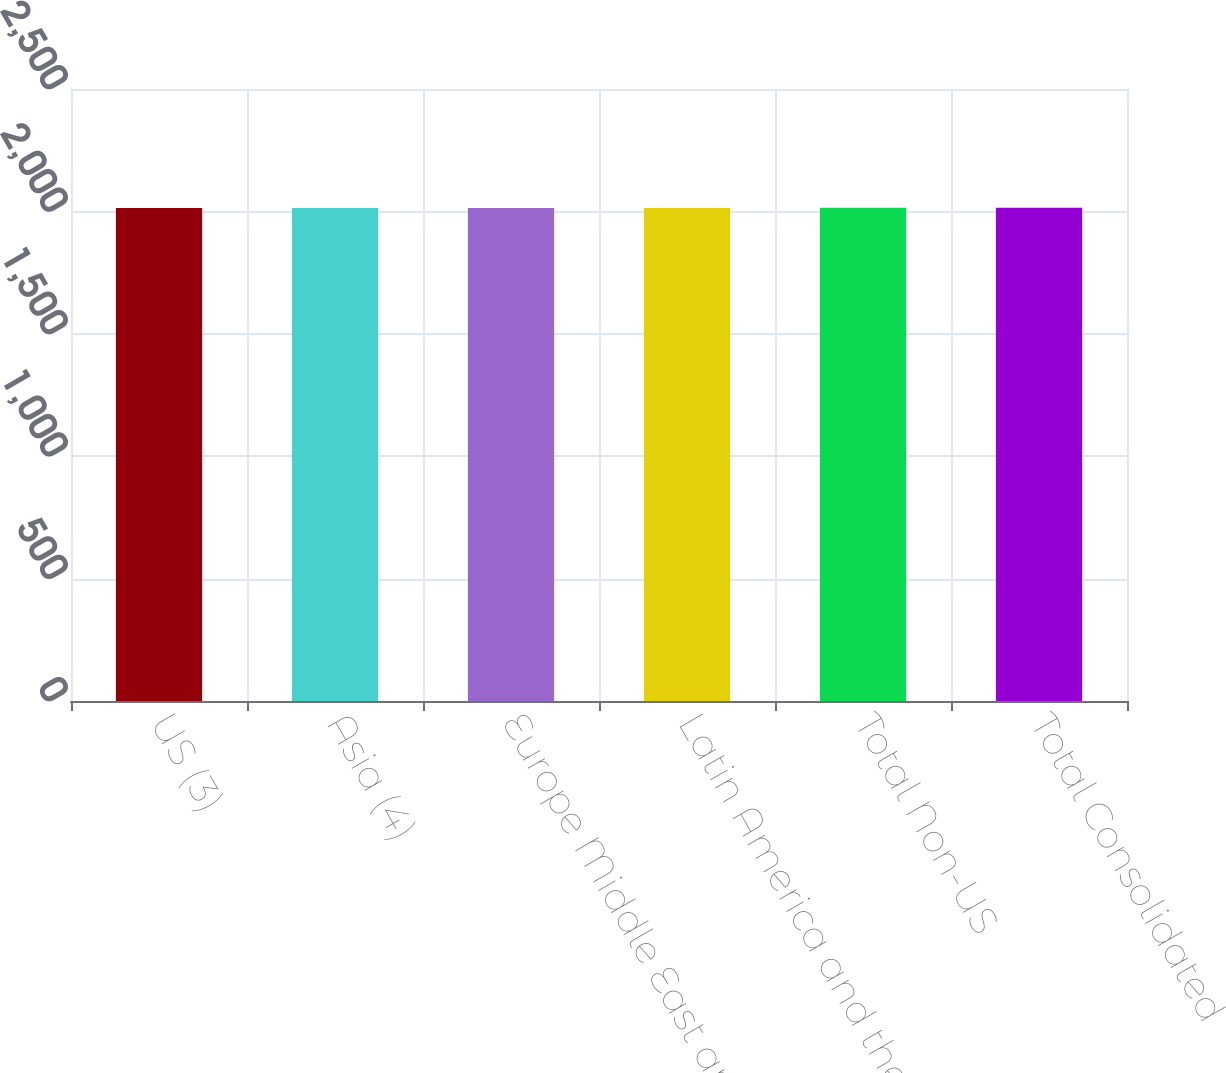<chart> <loc_0><loc_0><loc_500><loc_500><bar_chart><fcel>US (3)<fcel>Asia (4)<fcel>Europe Middle East and Africa<fcel>Latin America and the<fcel>Total Non-US<fcel>Total Consolidated<nl><fcel>2014<fcel>2014.1<fcel>2014.2<fcel>2014.3<fcel>2014.4<fcel>2014.5<nl></chart> 